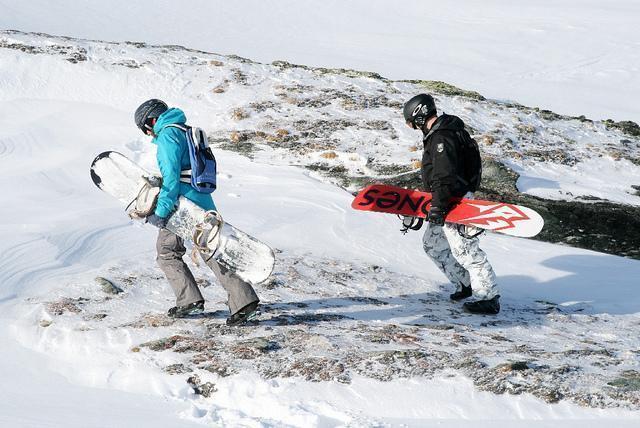What name is on the bottom of the ski board?
Select the accurate answer and provide justification: `Answer: choice
Rationale: srationale.`
Options: Jackson, yamaha, goose, jones. Answer: jones.
Rationale: The name is jones. 